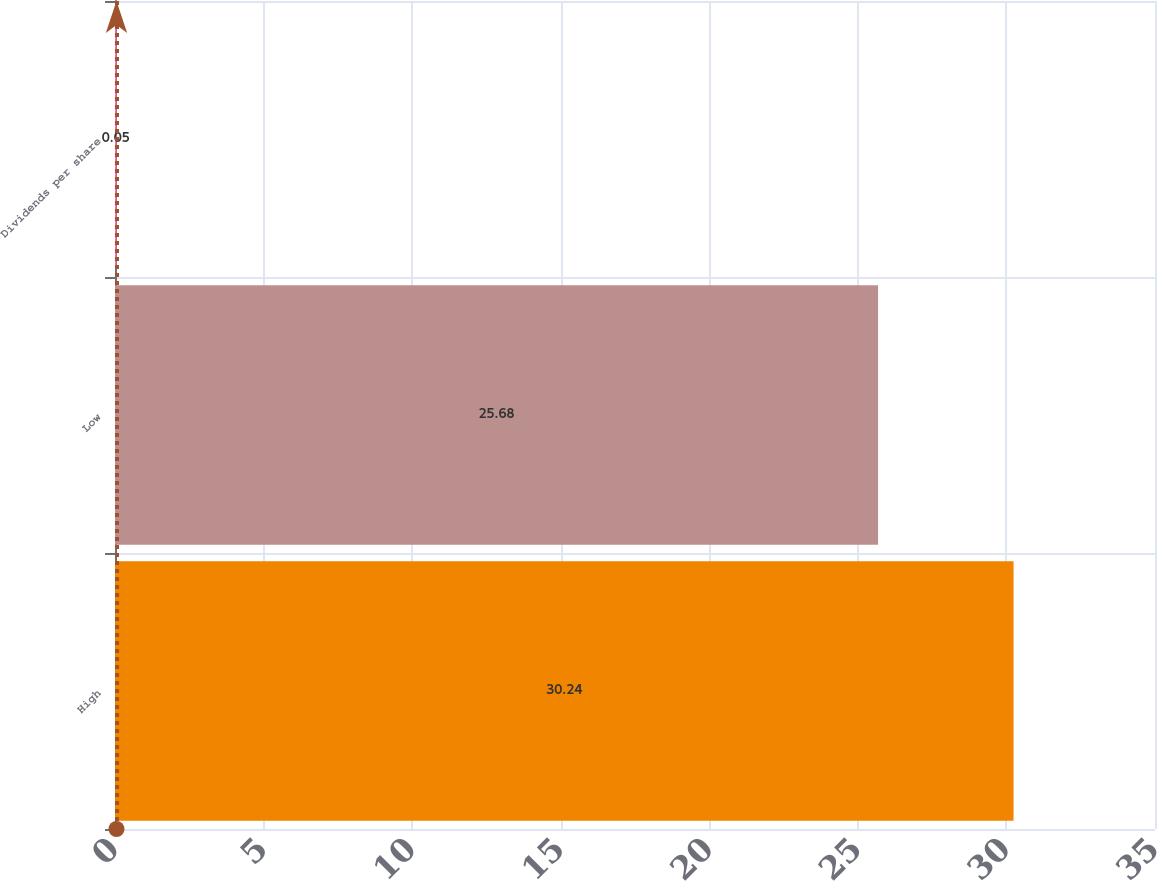Convert chart to OTSL. <chart><loc_0><loc_0><loc_500><loc_500><bar_chart><fcel>High<fcel>Low<fcel>Dividends per share<nl><fcel>30.24<fcel>25.68<fcel>0.05<nl></chart> 